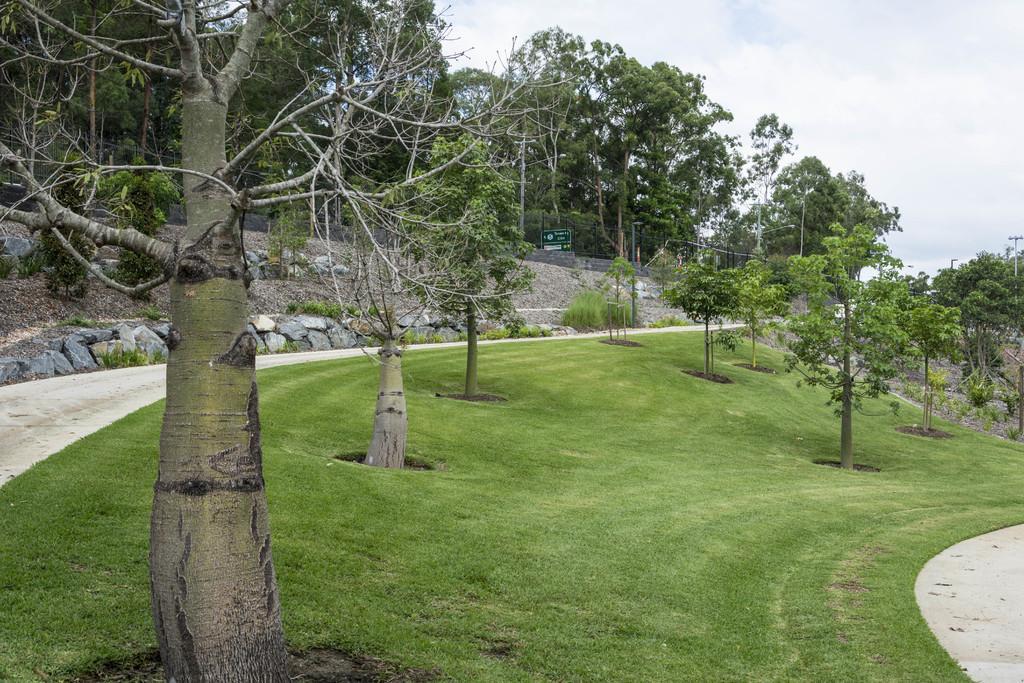Could you give a brief overview of what you see in this image? Here we can see trees and grass on the ground and on the left and right we can see path. In the background there are trees,poles,stones,hoarding and clouds in the sky. 